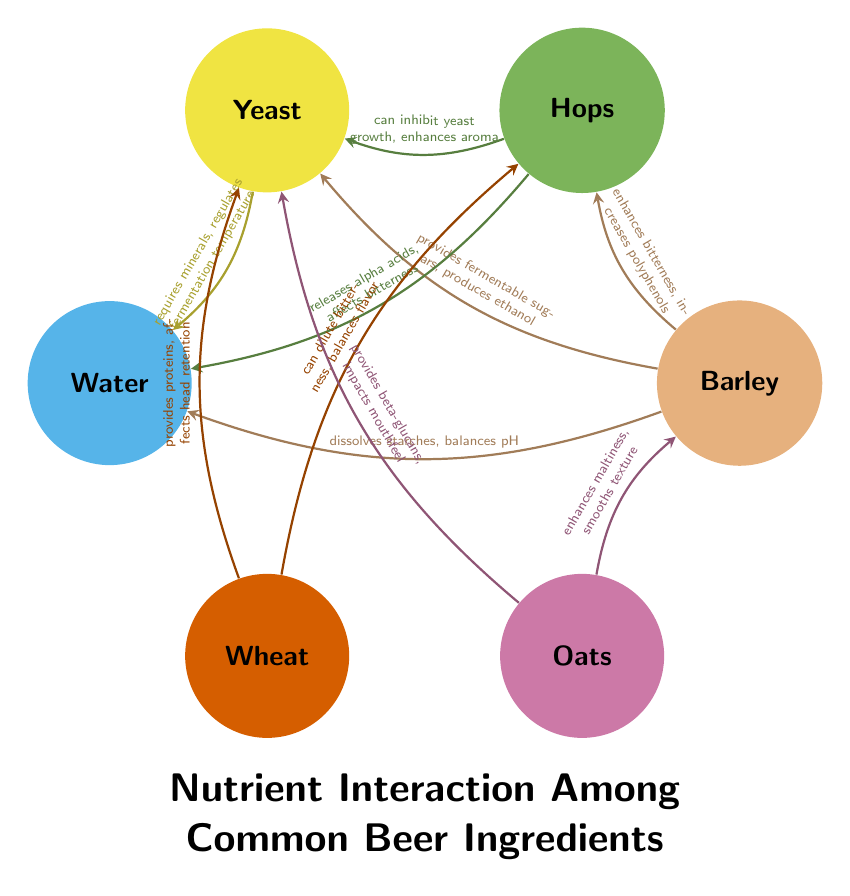What are the main ingredients shown in the diagram? The diagram features six ingredients: Barley, Hops, Yeast, Water, Wheat, and Oats. These are labeled as nodes in the diagram.
Answer: Barley, Hops, Yeast, Water, Wheat, Oats How many interactions are listed in the diagram? There are a total of ten interactions connecting the ingredients. Each interaction is represented as an arrow between two nodes, indicating the relationship.
Answer: 10 What does Barley enhance in relation to Hops? According to the diagram, Barley enhances bitterness and increases polyphenols when interacting with Hops. This relationship is mentioned on the connecting arrow between the two.
Answer: enhances bitterness, increases polyphenols Which ingredient requires minerals for regulation? The diagram indicates that Yeast requires minerals, as noted in the interaction that connects Yeast to Water. This information can be found on the arrow linking these two nodes.
Answer: Yeast What effect do Oats have on Yeast? The diagram states that Oats provide beta-glucans and impact mouthfeel in relation to Yeast. This is detailed in the interaction noted on the arrow connecting Oats to Yeast.
Answer: provides beta-glucans, impacts mouthfeel How does Wheat affect the flavor of Hops? The diagram shows that Wheat can dilute bitterness and balances flavor when interacting with Hops. These effects are explicitly mentioned on the arrow connecting the two nodes.
Answer: can dilute bitterness, balances flavor Which two ingredients interact to affect mouthfeel? The ingredients that interact to impact mouthfeel are Oats and Yeast, as indicated by the connection and the specific interaction described on the arrow between them.
Answer: Oats, Yeast How do Hops and Yeast interact in the brewing process? Hops can inhibit yeast growth and enhances aroma, as shown in the interaction line connecting Hops to Yeast. This highlights a potential negative influence of Hops on Yeast activity.
Answer: can inhibit yeast growth, enhances aroma Which ingredient modifies the texture of Barley? Oats enhance maltiness and smooth texture in relation to Barley, as specified on the interaction arrow between these two ingredients in the diagram.
Answer: enhances maltiness, smooths texture 